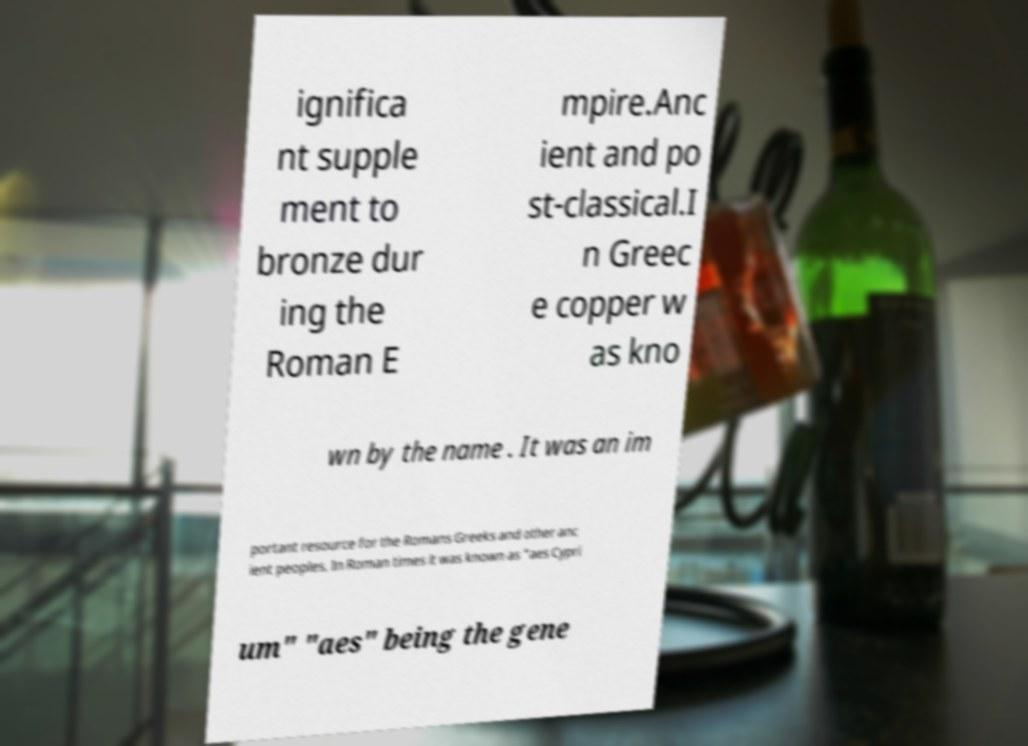I need the written content from this picture converted into text. Can you do that? ignifica nt supple ment to bronze dur ing the Roman E mpire.Anc ient and po st-classical.I n Greec e copper w as kno wn by the name . It was an im portant resource for the Romans Greeks and other anc ient peoples. In Roman times it was known as "aes Cypri um" "aes" being the gene 